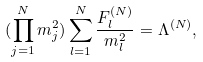Convert formula to latex. <formula><loc_0><loc_0><loc_500><loc_500>( \prod _ { j = 1 } ^ { N } m _ { j } ^ { 2 } ) \sum _ { l = 1 } ^ { N } \frac { F _ { l } ^ { ( N ) } } { m _ { l } ^ { 2 } } = \Lambda ^ { ( N ) } ,</formula> 